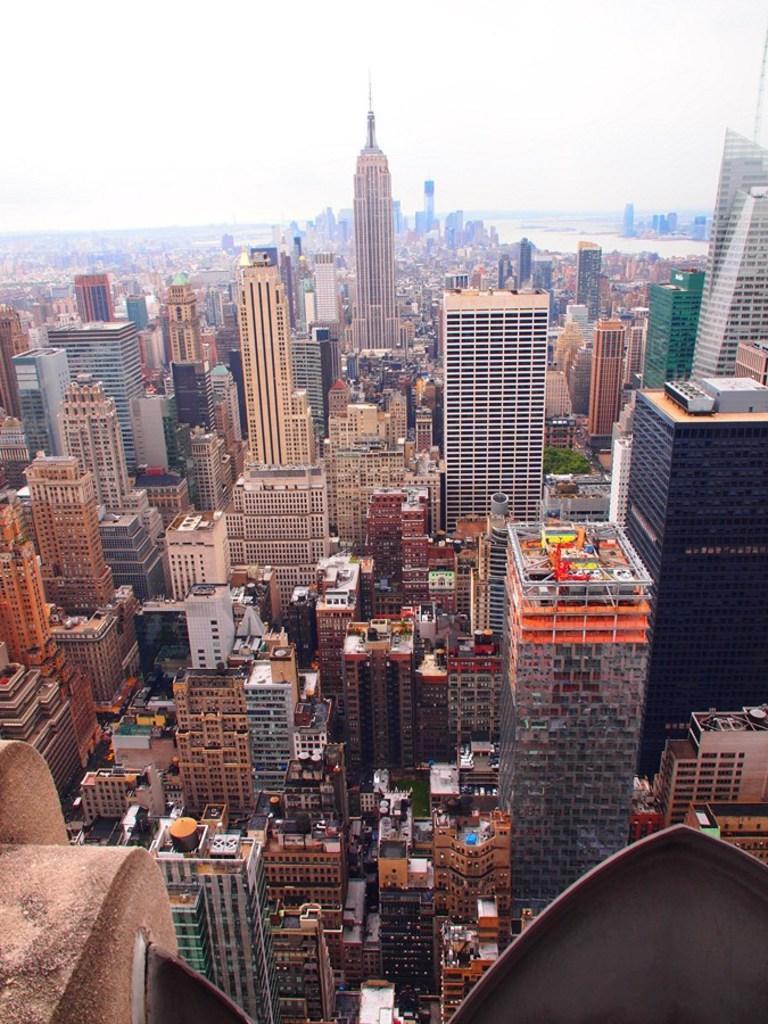Can you describe this image briefly? In this image we can see a group of buildings, towers and some trees. On the backside we can see a water body and the sky which looks cloudy. 